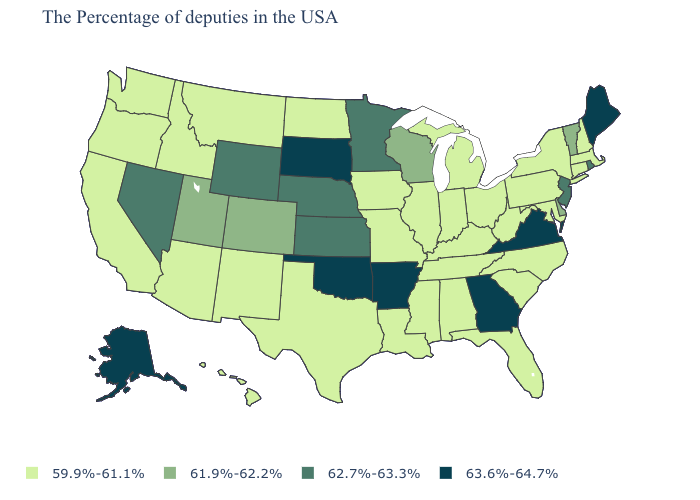Among the states that border Texas , which have the highest value?
Short answer required. Arkansas, Oklahoma. What is the lowest value in the USA?
Quick response, please. 59.9%-61.1%. Does Vermont have the lowest value in the USA?
Give a very brief answer. No. What is the value of New Hampshire?
Quick response, please. 59.9%-61.1%. Does Montana have the highest value in the West?
Concise answer only. No. Name the states that have a value in the range 63.6%-64.7%?
Give a very brief answer. Maine, Virginia, Georgia, Arkansas, Oklahoma, South Dakota, Alaska. Name the states that have a value in the range 63.6%-64.7%?
Answer briefly. Maine, Virginia, Georgia, Arkansas, Oklahoma, South Dakota, Alaska. Among the states that border Mississippi , does Arkansas have the lowest value?
Give a very brief answer. No. What is the lowest value in the South?
Be succinct. 59.9%-61.1%. Does Georgia have the highest value in the USA?
Write a very short answer. Yes. What is the value of Georgia?
Give a very brief answer. 63.6%-64.7%. Name the states that have a value in the range 62.7%-63.3%?
Short answer required. Rhode Island, New Jersey, Minnesota, Kansas, Nebraska, Wyoming, Nevada. Does Alaska have the highest value in the West?
Short answer required. Yes. What is the value of Delaware?
Write a very short answer. 61.9%-62.2%. 